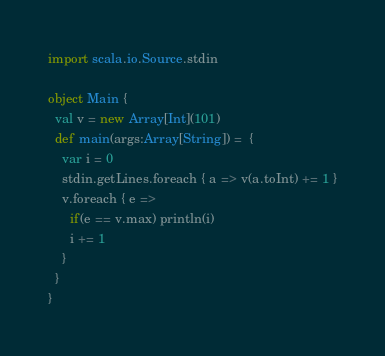Convert code to text. <code><loc_0><loc_0><loc_500><loc_500><_Scala_>import scala.io.Source.stdin

object Main {
  val v = new Array[Int](101)
  def main(args:Array[String]) =  {
    var i = 0
    stdin.getLines.foreach { a => v(a.toInt) += 1 }
    v.foreach { e =>
      if(e == v.max) println(i)
      i += 1
    }
  }
}</code> 